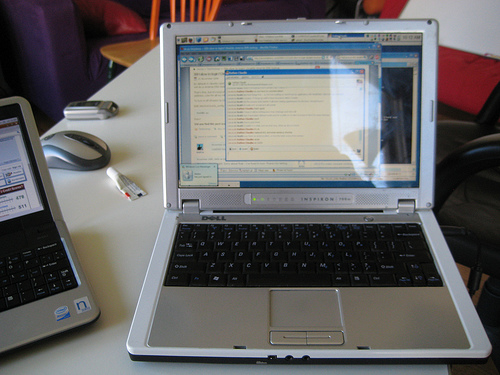<image>
Is there a laptop behind the mouse? No. The laptop is not behind the mouse. From this viewpoint, the laptop appears to be positioned elsewhere in the scene. Is the laptop on the chair? No. The laptop is not positioned on the chair. They may be near each other, but the laptop is not supported by or resting on top of the chair. 